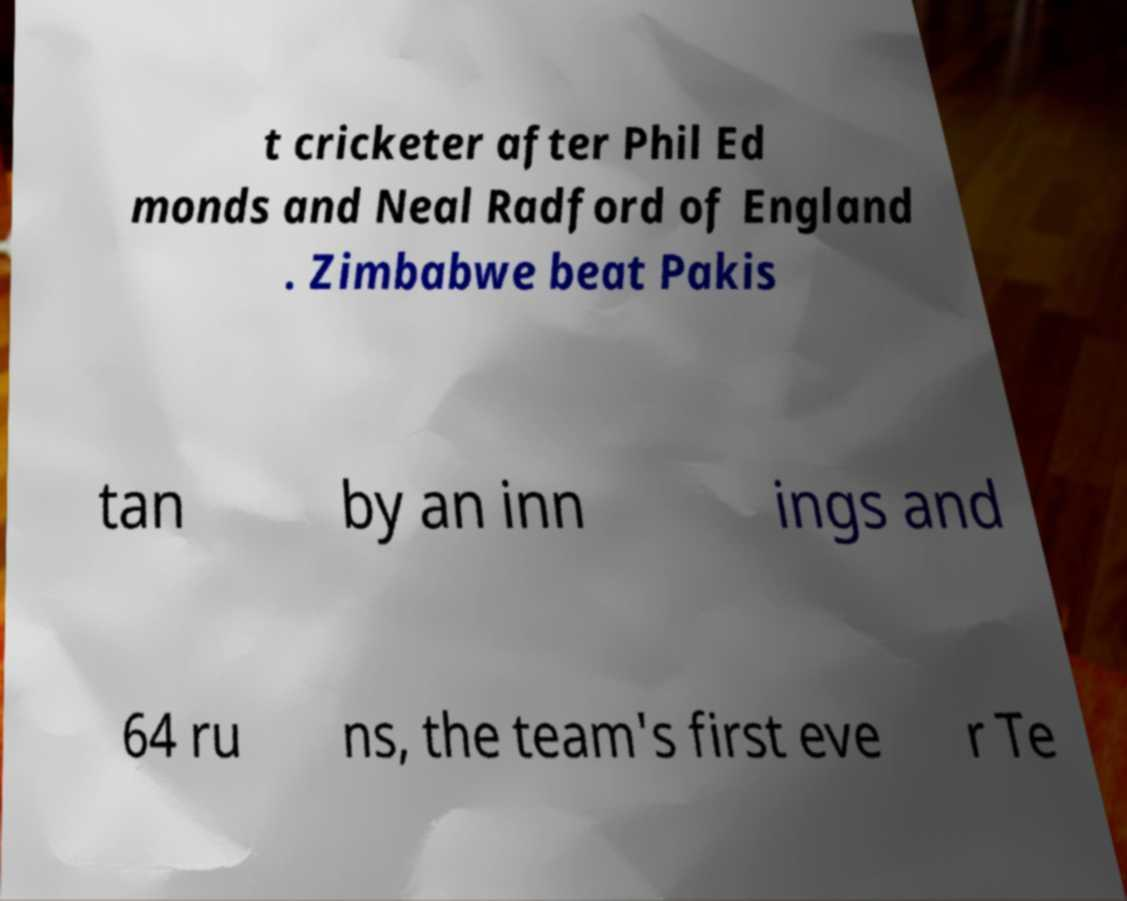Please read and relay the text visible in this image. What does it say? t cricketer after Phil Ed monds and Neal Radford of England . Zimbabwe beat Pakis tan by an inn ings and 64 ru ns, the team's first eve r Te 